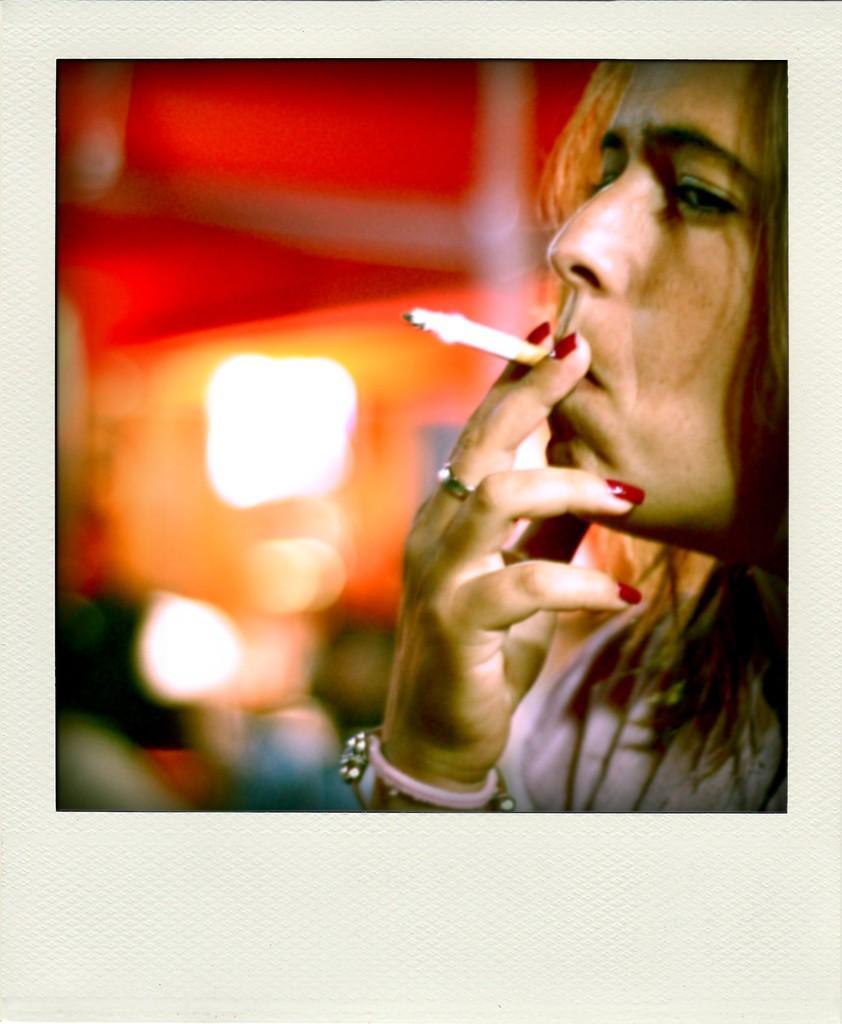Please provide a concise description of this image. In this picture there is a woman towards the right and she is smoking. 